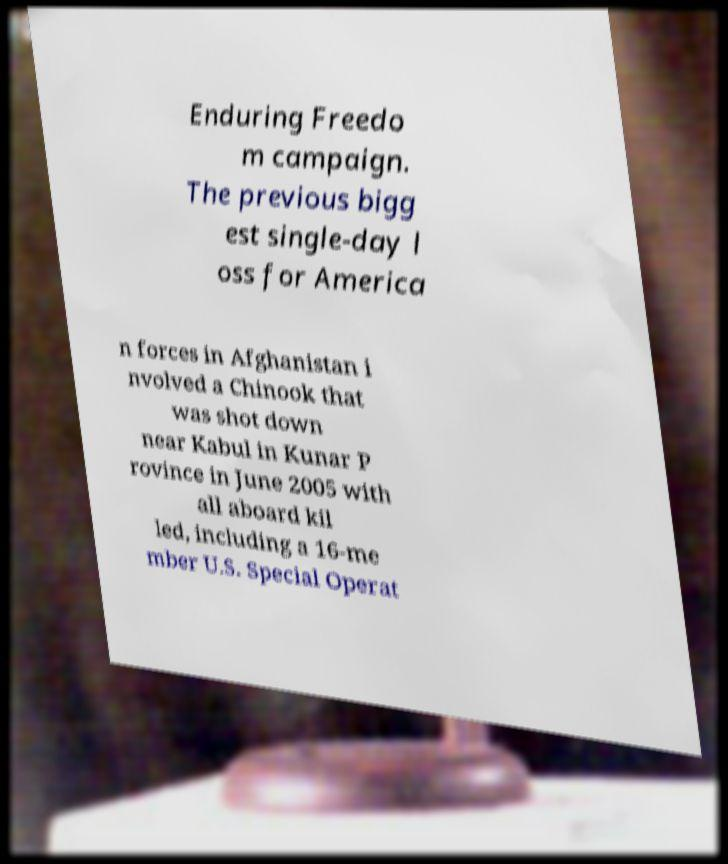Please read and relay the text visible in this image. What does it say? Enduring Freedo m campaign. The previous bigg est single-day l oss for America n forces in Afghanistan i nvolved a Chinook that was shot down near Kabul in Kunar P rovince in June 2005 with all aboard kil led, including a 16-me mber U.S. Special Operat 